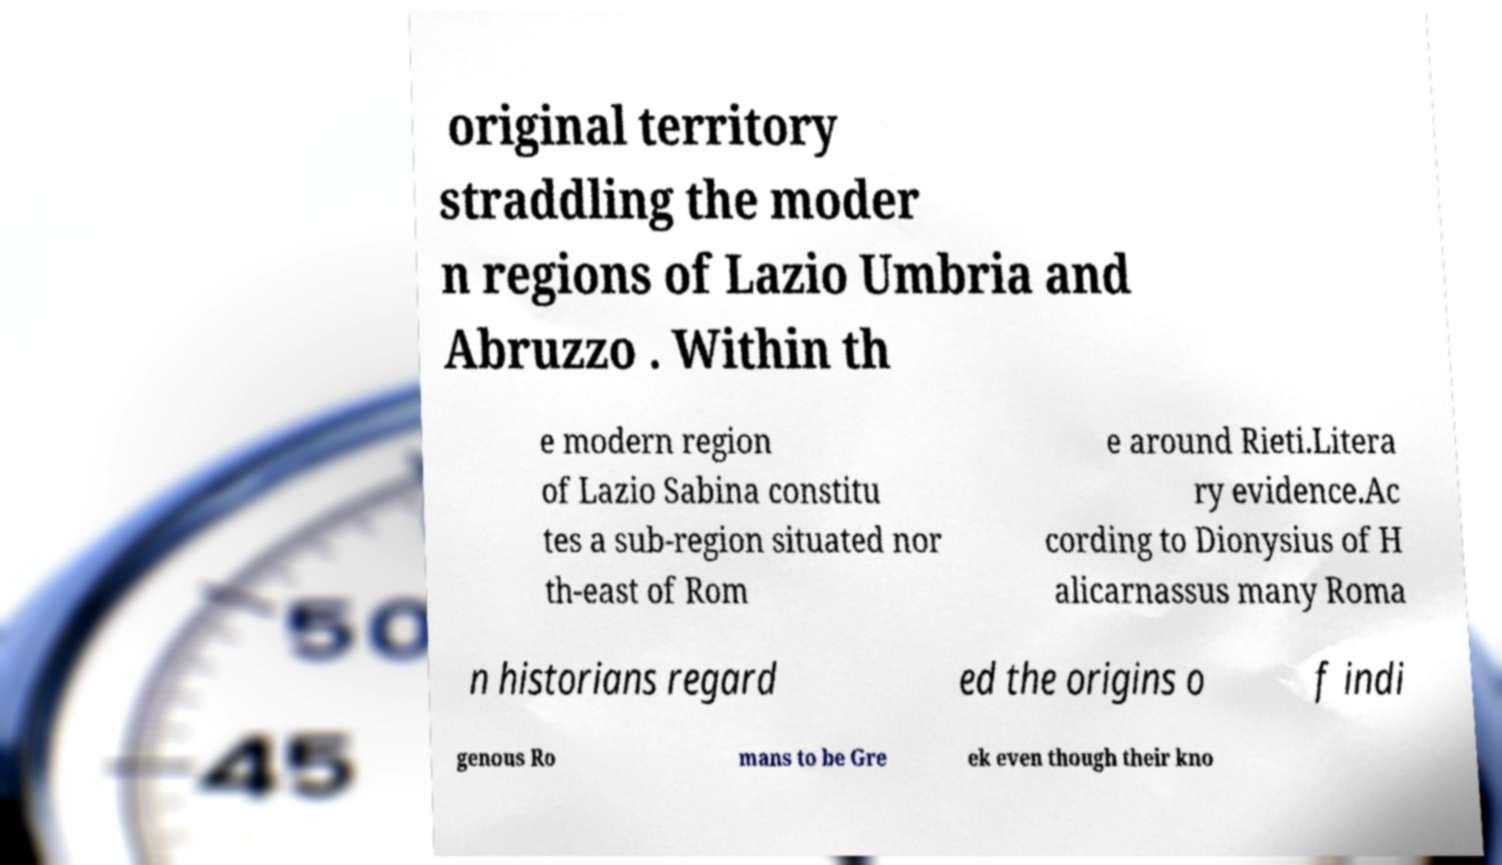Please read and relay the text visible in this image. What does it say? original territory straddling the moder n regions of Lazio Umbria and Abruzzo . Within th e modern region of Lazio Sabina constitu tes a sub-region situated nor th-east of Rom e around Rieti.Litera ry evidence.Ac cording to Dionysius of H alicarnassus many Roma n historians regard ed the origins o f indi genous Ro mans to be Gre ek even though their kno 